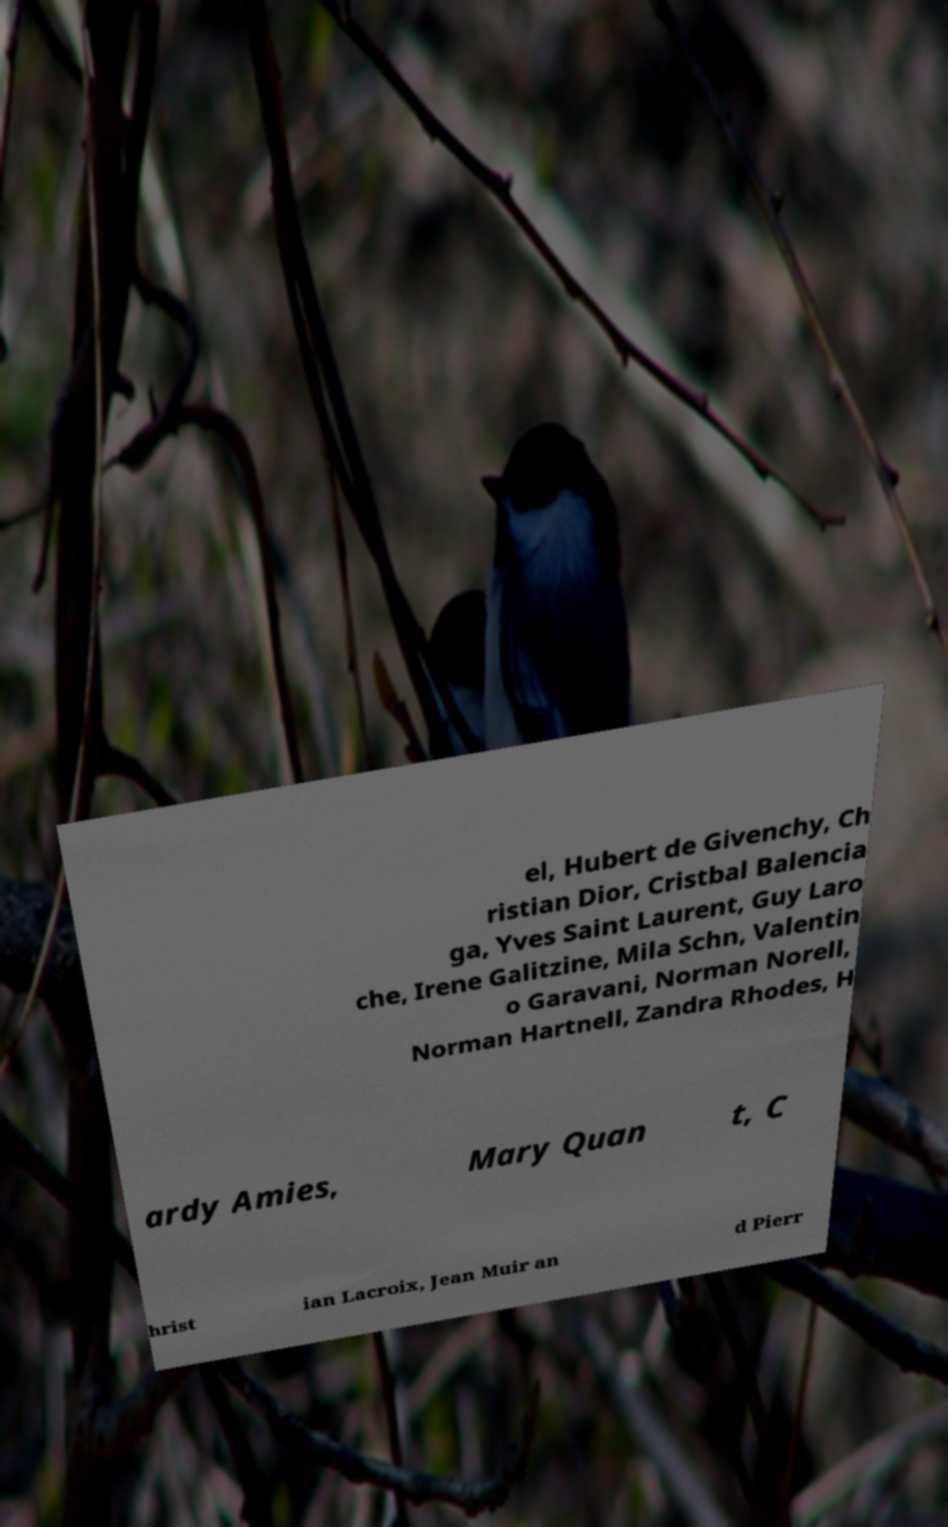Can you read and provide the text displayed in the image?This photo seems to have some interesting text. Can you extract and type it out for me? el, Hubert de Givenchy, Ch ristian Dior, Cristbal Balencia ga, Yves Saint Laurent, Guy Laro che, Irene Galitzine, Mila Schn, Valentin o Garavani, Norman Norell, Norman Hartnell, Zandra Rhodes, H ardy Amies, Mary Quan t, C hrist ian Lacroix, Jean Muir an d Pierr 